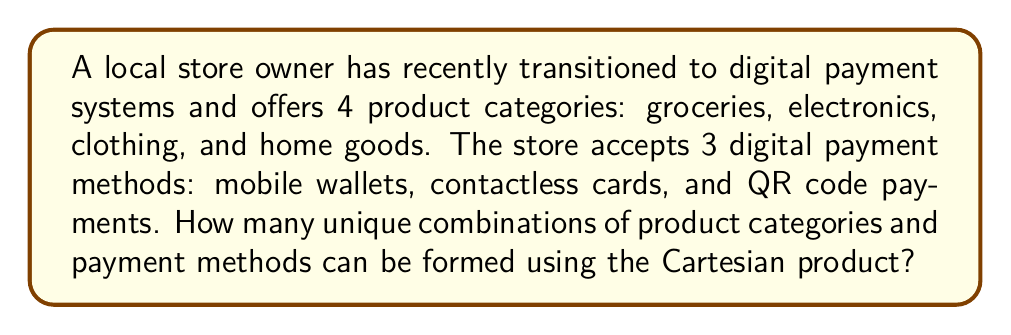Give your solution to this math problem. To solve this problem, we need to understand the concept of Cartesian product and apply it to the given scenario.

1. Define the sets:
   Let A = {groceries, electronics, clothing, home goods}
   Let B = {mobile wallets, contactless cards, QR code payments}

2. The Cartesian product of sets A and B, denoted as A × B, is the set of all ordered pairs (a, b) where a ∈ A and b ∈ B.

3. To calculate the number of elements in the Cartesian product, we use the formula:
   $$ |A \times B| = |A| \cdot |B| $$
   Where |A| represents the number of elements in set A, and |B| represents the number of elements in set B.

4. In this case:
   $$ |A| = 4 \text{ (number of product categories)} $$
   $$ |B| = 3 \text{ (number of payment methods)} $$

5. Apply the formula:
   $$ |A \times B| = |A| \cdot |B| = 4 \cdot 3 = 12 $$

Therefore, there are 12 unique combinations of product categories and payment methods.
Answer: $$ |A \times B| = 12 \text{ unique combinations} $$ 